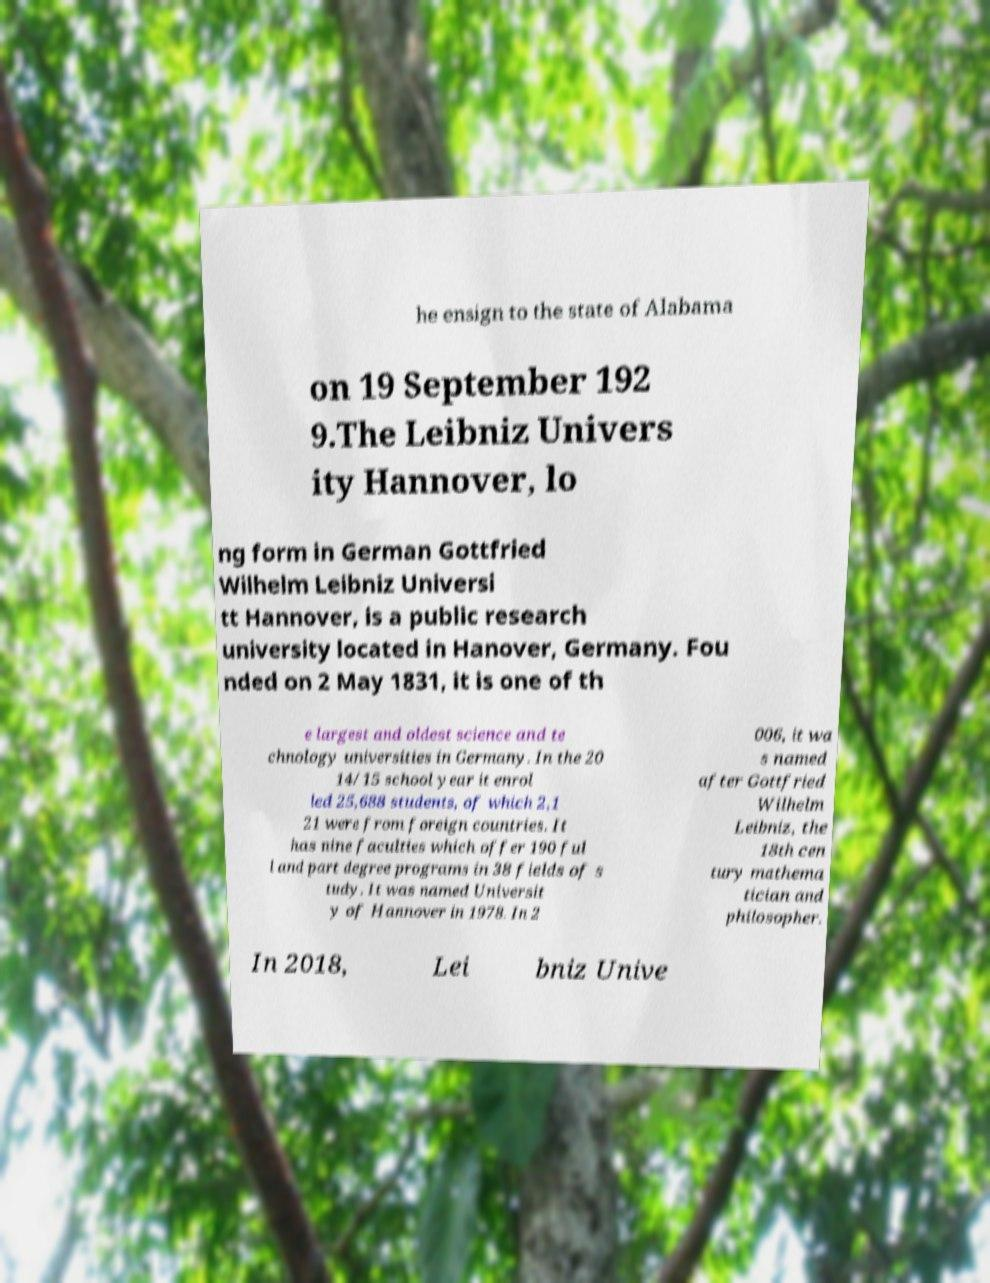Please read and relay the text visible in this image. What does it say? he ensign to the state of Alabama on 19 September 192 9.The Leibniz Univers ity Hannover, lo ng form in German Gottfried Wilhelm Leibniz Universi tt Hannover, is a public research university located in Hanover, Germany. Fou nded on 2 May 1831, it is one of th e largest and oldest science and te chnology universities in Germany. In the 20 14/15 school year it enrol led 25,688 students, of which 2,1 21 were from foreign countries. It has nine faculties which offer 190 ful l and part degree programs in 38 fields of s tudy. It was named Universit y of Hannover in 1978. In 2 006, it wa s named after Gottfried Wilhelm Leibniz, the 18th cen tury mathema tician and philosopher. In 2018, Lei bniz Unive 